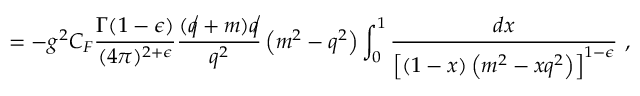Convert formula to latex. <formula><loc_0><loc_0><loc_500><loc_500>= - g ^ { 2 } C _ { F } \frac { \Gamma ( 1 - \epsilon ) } { ( 4 \pi ) ^ { 2 + \epsilon } } \frac { ( \not q + m ) \not q } { q ^ { 2 } } \left ( m ^ { 2 } - q ^ { 2 } \right ) \int _ { 0 } ^ { 1 } \frac { d x } { \left [ ( 1 - x ) \left ( m ^ { 2 } - x q ^ { 2 } \right ) \right ] ^ { 1 - \epsilon } } ,</formula> 